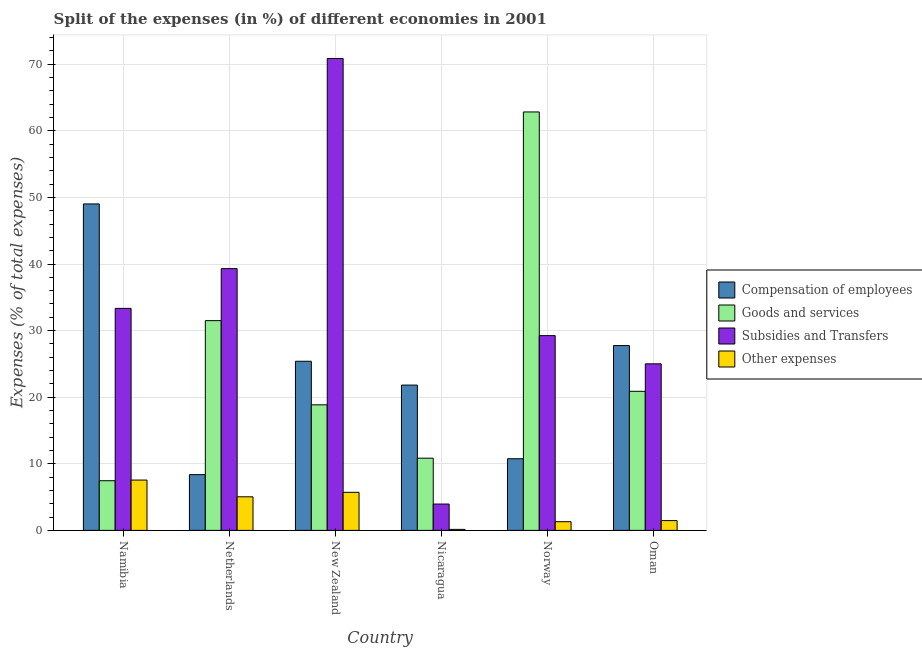How many groups of bars are there?
Keep it short and to the point. 6. What is the percentage of amount spent on subsidies in Namibia?
Offer a terse response. 33.34. Across all countries, what is the maximum percentage of amount spent on other expenses?
Provide a succinct answer. 7.56. Across all countries, what is the minimum percentage of amount spent on compensation of employees?
Offer a terse response. 8.37. In which country was the percentage of amount spent on goods and services maximum?
Make the answer very short. Norway. In which country was the percentage of amount spent on goods and services minimum?
Your response must be concise. Namibia. What is the total percentage of amount spent on other expenses in the graph?
Your answer should be very brief. 21.25. What is the difference between the percentage of amount spent on subsidies in New Zealand and that in Norway?
Give a very brief answer. 41.62. What is the difference between the percentage of amount spent on subsidies in New Zealand and the percentage of amount spent on compensation of employees in Norway?
Provide a short and direct response. 60.11. What is the average percentage of amount spent on other expenses per country?
Offer a terse response. 3.54. What is the difference between the percentage of amount spent on other expenses and percentage of amount spent on subsidies in Netherlands?
Your answer should be very brief. -34.26. In how many countries, is the percentage of amount spent on other expenses greater than 18 %?
Offer a very short reply. 0. What is the ratio of the percentage of amount spent on subsidies in Nicaragua to that in Norway?
Provide a short and direct response. 0.14. Is the difference between the percentage of amount spent on goods and services in Nicaragua and Oman greater than the difference between the percentage of amount spent on compensation of employees in Nicaragua and Oman?
Your answer should be compact. No. What is the difference between the highest and the second highest percentage of amount spent on subsidies?
Offer a terse response. 31.56. What is the difference between the highest and the lowest percentage of amount spent on compensation of employees?
Keep it short and to the point. 40.65. Is the sum of the percentage of amount spent on other expenses in Nicaragua and Oman greater than the maximum percentage of amount spent on compensation of employees across all countries?
Give a very brief answer. No. Is it the case that in every country, the sum of the percentage of amount spent on goods and services and percentage of amount spent on other expenses is greater than the sum of percentage of amount spent on subsidies and percentage of amount spent on compensation of employees?
Make the answer very short. No. What does the 4th bar from the left in Nicaragua represents?
Provide a succinct answer. Other expenses. What does the 3rd bar from the right in Oman represents?
Give a very brief answer. Goods and services. Is it the case that in every country, the sum of the percentage of amount spent on compensation of employees and percentage of amount spent on goods and services is greater than the percentage of amount spent on subsidies?
Ensure brevity in your answer.  No. How many countries are there in the graph?
Give a very brief answer. 6. Does the graph contain any zero values?
Offer a very short reply. No. Where does the legend appear in the graph?
Give a very brief answer. Center right. What is the title of the graph?
Your answer should be very brief. Split of the expenses (in %) of different economies in 2001. Does "Taxes on income" appear as one of the legend labels in the graph?
Ensure brevity in your answer.  No. What is the label or title of the Y-axis?
Provide a short and direct response. Expenses (% of total expenses). What is the Expenses (% of total expenses) of Compensation of employees in Namibia?
Your response must be concise. 49.02. What is the Expenses (% of total expenses) in Goods and services in Namibia?
Your answer should be compact. 7.46. What is the Expenses (% of total expenses) of Subsidies and Transfers in Namibia?
Your answer should be very brief. 33.34. What is the Expenses (% of total expenses) in Other expenses in Namibia?
Your answer should be very brief. 7.56. What is the Expenses (% of total expenses) in Compensation of employees in Netherlands?
Offer a terse response. 8.37. What is the Expenses (% of total expenses) in Goods and services in Netherlands?
Offer a very short reply. 31.5. What is the Expenses (% of total expenses) in Subsidies and Transfers in Netherlands?
Give a very brief answer. 39.31. What is the Expenses (% of total expenses) in Other expenses in Netherlands?
Offer a terse response. 5.04. What is the Expenses (% of total expenses) in Compensation of employees in New Zealand?
Your answer should be very brief. 25.4. What is the Expenses (% of total expenses) of Goods and services in New Zealand?
Make the answer very short. 18.85. What is the Expenses (% of total expenses) of Subsidies and Transfers in New Zealand?
Make the answer very short. 70.87. What is the Expenses (% of total expenses) in Other expenses in New Zealand?
Your answer should be compact. 5.72. What is the Expenses (% of total expenses) in Compensation of employees in Nicaragua?
Make the answer very short. 21.82. What is the Expenses (% of total expenses) in Goods and services in Nicaragua?
Ensure brevity in your answer.  10.84. What is the Expenses (% of total expenses) of Subsidies and Transfers in Nicaragua?
Your answer should be compact. 3.96. What is the Expenses (% of total expenses) of Other expenses in Nicaragua?
Your answer should be very brief. 0.15. What is the Expenses (% of total expenses) of Compensation of employees in Norway?
Offer a very short reply. 10.76. What is the Expenses (% of total expenses) in Goods and services in Norway?
Offer a very short reply. 62.83. What is the Expenses (% of total expenses) in Subsidies and Transfers in Norway?
Your answer should be very brief. 29.25. What is the Expenses (% of total expenses) of Other expenses in Norway?
Give a very brief answer. 1.31. What is the Expenses (% of total expenses) in Compensation of employees in Oman?
Offer a very short reply. 27.75. What is the Expenses (% of total expenses) of Goods and services in Oman?
Keep it short and to the point. 20.88. What is the Expenses (% of total expenses) in Subsidies and Transfers in Oman?
Provide a succinct answer. 25.01. What is the Expenses (% of total expenses) in Other expenses in Oman?
Your answer should be very brief. 1.47. Across all countries, what is the maximum Expenses (% of total expenses) in Compensation of employees?
Provide a short and direct response. 49.02. Across all countries, what is the maximum Expenses (% of total expenses) of Goods and services?
Your answer should be very brief. 62.83. Across all countries, what is the maximum Expenses (% of total expenses) of Subsidies and Transfers?
Provide a succinct answer. 70.87. Across all countries, what is the maximum Expenses (% of total expenses) of Other expenses?
Offer a very short reply. 7.56. Across all countries, what is the minimum Expenses (% of total expenses) of Compensation of employees?
Your answer should be very brief. 8.37. Across all countries, what is the minimum Expenses (% of total expenses) in Goods and services?
Provide a succinct answer. 7.46. Across all countries, what is the minimum Expenses (% of total expenses) in Subsidies and Transfers?
Make the answer very short. 3.96. Across all countries, what is the minimum Expenses (% of total expenses) in Other expenses?
Ensure brevity in your answer.  0.15. What is the total Expenses (% of total expenses) of Compensation of employees in the graph?
Your response must be concise. 143.12. What is the total Expenses (% of total expenses) of Goods and services in the graph?
Give a very brief answer. 152.37. What is the total Expenses (% of total expenses) in Subsidies and Transfers in the graph?
Provide a succinct answer. 201.72. What is the total Expenses (% of total expenses) in Other expenses in the graph?
Offer a terse response. 21.25. What is the difference between the Expenses (% of total expenses) in Compensation of employees in Namibia and that in Netherlands?
Offer a terse response. 40.65. What is the difference between the Expenses (% of total expenses) of Goods and services in Namibia and that in Netherlands?
Offer a terse response. -24.04. What is the difference between the Expenses (% of total expenses) of Subsidies and Transfers in Namibia and that in Netherlands?
Keep it short and to the point. -5.97. What is the difference between the Expenses (% of total expenses) in Other expenses in Namibia and that in Netherlands?
Provide a short and direct response. 2.51. What is the difference between the Expenses (% of total expenses) in Compensation of employees in Namibia and that in New Zealand?
Provide a succinct answer. 23.63. What is the difference between the Expenses (% of total expenses) in Goods and services in Namibia and that in New Zealand?
Make the answer very short. -11.4. What is the difference between the Expenses (% of total expenses) in Subsidies and Transfers in Namibia and that in New Zealand?
Ensure brevity in your answer.  -37.53. What is the difference between the Expenses (% of total expenses) in Other expenses in Namibia and that in New Zealand?
Make the answer very short. 1.84. What is the difference between the Expenses (% of total expenses) in Compensation of employees in Namibia and that in Nicaragua?
Provide a succinct answer. 27.2. What is the difference between the Expenses (% of total expenses) of Goods and services in Namibia and that in Nicaragua?
Provide a succinct answer. -3.38. What is the difference between the Expenses (% of total expenses) of Subsidies and Transfers in Namibia and that in Nicaragua?
Your response must be concise. 29.38. What is the difference between the Expenses (% of total expenses) of Other expenses in Namibia and that in Nicaragua?
Your answer should be compact. 7.4. What is the difference between the Expenses (% of total expenses) in Compensation of employees in Namibia and that in Norway?
Ensure brevity in your answer.  38.26. What is the difference between the Expenses (% of total expenses) in Goods and services in Namibia and that in Norway?
Your response must be concise. -55.38. What is the difference between the Expenses (% of total expenses) of Subsidies and Transfers in Namibia and that in Norway?
Your response must be concise. 4.09. What is the difference between the Expenses (% of total expenses) in Other expenses in Namibia and that in Norway?
Your response must be concise. 6.25. What is the difference between the Expenses (% of total expenses) of Compensation of employees in Namibia and that in Oman?
Keep it short and to the point. 21.27. What is the difference between the Expenses (% of total expenses) in Goods and services in Namibia and that in Oman?
Offer a terse response. -13.43. What is the difference between the Expenses (% of total expenses) in Subsidies and Transfers in Namibia and that in Oman?
Ensure brevity in your answer.  8.33. What is the difference between the Expenses (% of total expenses) of Other expenses in Namibia and that in Oman?
Ensure brevity in your answer.  6.09. What is the difference between the Expenses (% of total expenses) in Compensation of employees in Netherlands and that in New Zealand?
Make the answer very short. -17.03. What is the difference between the Expenses (% of total expenses) of Goods and services in Netherlands and that in New Zealand?
Give a very brief answer. 12.64. What is the difference between the Expenses (% of total expenses) of Subsidies and Transfers in Netherlands and that in New Zealand?
Provide a succinct answer. -31.56. What is the difference between the Expenses (% of total expenses) in Other expenses in Netherlands and that in New Zealand?
Keep it short and to the point. -0.67. What is the difference between the Expenses (% of total expenses) in Compensation of employees in Netherlands and that in Nicaragua?
Keep it short and to the point. -13.45. What is the difference between the Expenses (% of total expenses) in Goods and services in Netherlands and that in Nicaragua?
Your response must be concise. 20.65. What is the difference between the Expenses (% of total expenses) of Subsidies and Transfers in Netherlands and that in Nicaragua?
Make the answer very short. 35.35. What is the difference between the Expenses (% of total expenses) in Other expenses in Netherlands and that in Nicaragua?
Your answer should be very brief. 4.89. What is the difference between the Expenses (% of total expenses) in Compensation of employees in Netherlands and that in Norway?
Give a very brief answer. -2.39. What is the difference between the Expenses (% of total expenses) in Goods and services in Netherlands and that in Norway?
Provide a succinct answer. -31.34. What is the difference between the Expenses (% of total expenses) in Subsidies and Transfers in Netherlands and that in Norway?
Provide a succinct answer. 10.06. What is the difference between the Expenses (% of total expenses) in Other expenses in Netherlands and that in Norway?
Make the answer very short. 3.74. What is the difference between the Expenses (% of total expenses) of Compensation of employees in Netherlands and that in Oman?
Provide a short and direct response. -19.38. What is the difference between the Expenses (% of total expenses) of Goods and services in Netherlands and that in Oman?
Ensure brevity in your answer.  10.61. What is the difference between the Expenses (% of total expenses) of Subsidies and Transfers in Netherlands and that in Oman?
Keep it short and to the point. 14.3. What is the difference between the Expenses (% of total expenses) of Other expenses in Netherlands and that in Oman?
Provide a short and direct response. 3.57. What is the difference between the Expenses (% of total expenses) in Compensation of employees in New Zealand and that in Nicaragua?
Your response must be concise. 3.58. What is the difference between the Expenses (% of total expenses) of Goods and services in New Zealand and that in Nicaragua?
Offer a very short reply. 8.01. What is the difference between the Expenses (% of total expenses) of Subsidies and Transfers in New Zealand and that in Nicaragua?
Ensure brevity in your answer.  66.91. What is the difference between the Expenses (% of total expenses) of Other expenses in New Zealand and that in Nicaragua?
Provide a short and direct response. 5.57. What is the difference between the Expenses (% of total expenses) in Compensation of employees in New Zealand and that in Norway?
Ensure brevity in your answer.  14.64. What is the difference between the Expenses (% of total expenses) in Goods and services in New Zealand and that in Norway?
Make the answer very short. -43.98. What is the difference between the Expenses (% of total expenses) in Subsidies and Transfers in New Zealand and that in Norway?
Your answer should be compact. 41.62. What is the difference between the Expenses (% of total expenses) in Other expenses in New Zealand and that in Norway?
Your response must be concise. 4.41. What is the difference between the Expenses (% of total expenses) of Compensation of employees in New Zealand and that in Oman?
Your answer should be compact. -2.35. What is the difference between the Expenses (% of total expenses) in Goods and services in New Zealand and that in Oman?
Your response must be concise. -2.03. What is the difference between the Expenses (% of total expenses) in Subsidies and Transfers in New Zealand and that in Oman?
Give a very brief answer. 45.86. What is the difference between the Expenses (% of total expenses) of Other expenses in New Zealand and that in Oman?
Your answer should be compact. 4.25. What is the difference between the Expenses (% of total expenses) of Compensation of employees in Nicaragua and that in Norway?
Your answer should be compact. 11.06. What is the difference between the Expenses (% of total expenses) of Goods and services in Nicaragua and that in Norway?
Provide a short and direct response. -51.99. What is the difference between the Expenses (% of total expenses) in Subsidies and Transfers in Nicaragua and that in Norway?
Give a very brief answer. -25.29. What is the difference between the Expenses (% of total expenses) of Other expenses in Nicaragua and that in Norway?
Ensure brevity in your answer.  -1.15. What is the difference between the Expenses (% of total expenses) in Compensation of employees in Nicaragua and that in Oman?
Give a very brief answer. -5.93. What is the difference between the Expenses (% of total expenses) in Goods and services in Nicaragua and that in Oman?
Your answer should be very brief. -10.04. What is the difference between the Expenses (% of total expenses) of Subsidies and Transfers in Nicaragua and that in Oman?
Your response must be concise. -21.05. What is the difference between the Expenses (% of total expenses) in Other expenses in Nicaragua and that in Oman?
Offer a very short reply. -1.32. What is the difference between the Expenses (% of total expenses) of Compensation of employees in Norway and that in Oman?
Your response must be concise. -16.99. What is the difference between the Expenses (% of total expenses) in Goods and services in Norway and that in Oman?
Your response must be concise. 41.95. What is the difference between the Expenses (% of total expenses) of Subsidies and Transfers in Norway and that in Oman?
Your answer should be compact. 4.24. What is the difference between the Expenses (% of total expenses) in Other expenses in Norway and that in Oman?
Your response must be concise. -0.17. What is the difference between the Expenses (% of total expenses) in Compensation of employees in Namibia and the Expenses (% of total expenses) in Goods and services in Netherlands?
Provide a succinct answer. 17.53. What is the difference between the Expenses (% of total expenses) of Compensation of employees in Namibia and the Expenses (% of total expenses) of Subsidies and Transfers in Netherlands?
Give a very brief answer. 9.72. What is the difference between the Expenses (% of total expenses) in Compensation of employees in Namibia and the Expenses (% of total expenses) in Other expenses in Netherlands?
Ensure brevity in your answer.  43.98. What is the difference between the Expenses (% of total expenses) in Goods and services in Namibia and the Expenses (% of total expenses) in Subsidies and Transfers in Netherlands?
Your response must be concise. -31.85. What is the difference between the Expenses (% of total expenses) in Goods and services in Namibia and the Expenses (% of total expenses) in Other expenses in Netherlands?
Provide a short and direct response. 2.41. What is the difference between the Expenses (% of total expenses) of Subsidies and Transfers in Namibia and the Expenses (% of total expenses) of Other expenses in Netherlands?
Provide a short and direct response. 28.29. What is the difference between the Expenses (% of total expenses) of Compensation of employees in Namibia and the Expenses (% of total expenses) of Goods and services in New Zealand?
Keep it short and to the point. 30.17. What is the difference between the Expenses (% of total expenses) in Compensation of employees in Namibia and the Expenses (% of total expenses) in Subsidies and Transfers in New Zealand?
Your answer should be compact. -21.84. What is the difference between the Expenses (% of total expenses) in Compensation of employees in Namibia and the Expenses (% of total expenses) in Other expenses in New Zealand?
Ensure brevity in your answer.  43.31. What is the difference between the Expenses (% of total expenses) in Goods and services in Namibia and the Expenses (% of total expenses) in Subsidies and Transfers in New Zealand?
Provide a succinct answer. -63.41. What is the difference between the Expenses (% of total expenses) of Goods and services in Namibia and the Expenses (% of total expenses) of Other expenses in New Zealand?
Your response must be concise. 1.74. What is the difference between the Expenses (% of total expenses) of Subsidies and Transfers in Namibia and the Expenses (% of total expenses) of Other expenses in New Zealand?
Keep it short and to the point. 27.62. What is the difference between the Expenses (% of total expenses) of Compensation of employees in Namibia and the Expenses (% of total expenses) of Goods and services in Nicaragua?
Keep it short and to the point. 38.18. What is the difference between the Expenses (% of total expenses) of Compensation of employees in Namibia and the Expenses (% of total expenses) of Subsidies and Transfers in Nicaragua?
Keep it short and to the point. 45.07. What is the difference between the Expenses (% of total expenses) in Compensation of employees in Namibia and the Expenses (% of total expenses) in Other expenses in Nicaragua?
Provide a succinct answer. 48.87. What is the difference between the Expenses (% of total expenses) of Goods and services in Namibia and the Expenses (% of total expenses) of Subsidies and Transfers in Nicaragua?
Your answer should be compact. 3.5. What is the difference between the Expenses (% of total expenses) of Goods and services in Namibia and the Expenses (% of total expenses) of Other expenses in Nicaragua?
Give a very brief answer. 7.31. What is the difference between the Expenses (% of total expenses) of Subsidies and Transfers in Namibia and the Expenses (% of total expenses) of Other expenses in Nicaragua?
Your answer should be compact. 33.18. What is the difference between the Expenses (% of total expenses) in Compensation of employees in Namibia and the Expenses (% of total expenses) in Goods and services in Norway?
Give a very brief answer. -13.81. What is the difference between the Expenses (% of total expenses) in Compensation of employees in Namibia and the Expenses (% of total expenses) in Subsidies and Transfers in Norway?
Provide a short and direct response. 19.78. What is the difference between the Expenses (% of total expenses) in Compensation of employees in Namibia and the Expenses (% of total expenses) in Other expenses in Norway?
Your response must be concise. 47.72. What is the difference between the Expenses (% of total expenses) of Goods and services in Namibia and the Expenses (% of total expenses) of Subsidies and Transfers in Norway?
Your response must be concise. -21.79. What is the difference between the Expenses (% of total expenses) of Goods and services in Namibia and the Expenses (% of total expenses) of Other expenses in Norway?
Give a very brief answer. 6.15. What is the difference between the Expenses (% of total expenses) in Subsidies and Transfers in Namibia and the Expenses (% of total expenses) in Other expenses in Norway?
Offer a terse response. 32.03. What is the difference between the Expenses (% of total expenses) in Compensation of employees in Namibia and the Expenses (% of total expenses) in Goods and services in Oman?
Your answer should be compact. 28.14. What is the difference between the Expenses (% of total expenses) in Compensation of employees in Namibia and the Expenses (% of total expenses) in Subsidies and Transfers in Oman?
Your response must be concise. 24.01. What is the difference between the Expenses (% of total expenses) of Compensation of employees in Namibia and the Expenses (% of total expenses) of Other expenses in Oman?
Provide a short and direct response. 47.55. What is the difference between the Expenses (% of total expenses) in Goods and services in Namibia and the Expenses (% of total expenses) in Subsidies and Transfers in Oman?
Your response must be concise. -17.55. What is the difference between the Expenses (% of total expenses) in Goods and services in Namibia and the Expenses (% of total expenses) in Other expenses in Oman?
Offer a terse response. 5.99. What is the difference between the Expenses (% of total expenses) in Subsidies and Transfers in Namibia and the Expenses (% of total expenses) in Other expenses in Oman?
Provide a succinct answer. 31.87. What is the difference between the Expenses (% of total expenses) of Compensation of employees in Netherlands and the Expenses (% of total expenses) of Goods and services in New Zealand?
Your answer should be compact. -10.48. What is the difference between the Expenses (% of total expenses) of Compensation of employees in Netherlands and the Expenses (% of total expenses) of Subsidies and Transfers in New Zealand?
Keep it short and to the point. -62.5. What is the difference between the Expenses (% of total expenses) of Compensation of employees in Netherlands and the Expenses (% of total expenses) of Other expenses in New Zealand?
Your answer should be compact. 2.65. What is the difference between the Expenses (% of total expenses) in Goods and services in Netherlands and the Expenses (% of total expenses) in Subsidies and Transfers in New Zealand?
Your answer should be very brief. -39.37. What is the difference between the Expenses (% of total expenses) in Goods and services in Netherlands and the Expenses (% of total expenses) in Other expenses in New Zealand?
Provide a succinct answer. 25.78. What is the difference between the Expenses (% of total expenses) in Subsidies and Transfers in Netherlands and the Expenses (% of total expenses) in Other expenses in New Zealand?
Offer a very short reply. 33.59. What is the difference between the Expenses (% of total expenses) in Compensation of employees in Netherlands and the Expenses (% of total expenses) in Goods and services in Nicaragua?
Your answer should be very brief. -2.47. What is the difference between the Expenses (% of total expenses) of Compensation of employees in Netherlands and the Expenses (% of total expenses) of Subsidies and Transfers in Nicaragua?
Ensure brevity in your answer.  4.41. What is the difference between the Expenses (% of total expenses) of Compensation of employees in Netherlands and the Expenses (% of total expenses) of Other expenses in Nicaragua?
Offer a terse response. 8.22. What is the difference between the Expenses (% of total expenses) of Goods and services in Netherlands and the Expenses (% of total expenses) of Subsidies and Transfers in Nicaragua?
Your answer should be very brief. 27.54. What is the difference between the Expenses (% of total expenses) in Goods and services in Netherlands and the Expenses (% of total expenses) in Other expenses in Nicaragua?
Offer a terse response. 31.34. What is the difference between the Expenses (% of total expenses) in Subsidies and Transfers in Netherlands and the Expenses (% of total expenses) in Other expenses in Nicaragua?
Your answer should be very brief. 39.16. What is the difference between the Expenses (% of total expenses) of Compensation of employees in Netherlands and the Expenses (% of total expenses) of Goods and services in Norway?
Give a very brief answer. -54.47. What is the difference between the Expenses (% of total expenses) of Compensation of employees in Netherlands and the Expenses (% of total expenses) of Subsidies and Transfers in Norway?
Your response must be concise. -20.88. What is the difference between the Expenses (% of total expenses) in Compensation of employees in Netherlands and the Expenses (% of total expenses) in Other expenses in Norway?
Make the answer very short. 7.06. What is the difference between the Expenses (% of total expenses) in Goods and services in Netherlands and the Expenses (% of total expenses) in Subsidies and Transfers in Norway?
Provide a short and direct response. 2.25. What is the difference between the Expenses (% of total expenses) of Goods and services in Netherlands and the Expenses (% of total expenses) of Other expenses in Norway?
Your response must be concise. 30.19. What is the difference between the Expenses (% of total expenses) of Subsidies and Transfers in Netherlands and the Expenses (% of total expenses) of Other expenses in Norway?
Your answer should be very brief. 38. What is the difference between the Expenses (% of total expenses) of Compensation of employees in Netherlands and the Expenses (% of total expenses) of Goods and services in Oman?
Make the answer very short. -12.52. What is the difference between the Expenses (% of total expenses) in Compensation of employees in Netherlands and the Expenses (% of total expenses) in Subsidies and Transfers in Oman?
Your answer should be compact. -16.64. What is the difference between the Expenses (% of total expenses) in Compensation of employees in Netherlands and the Expenses (% of total expenses) in Other expenses in Oman?
Give a very brief answer. 6.9. What is the difference between the Expenses (% of total expenses) in Goods and services in Netherlands and the Expenses (% of total expenses) in Subsidies and Transfers in Oman?
Your response must be concise. 6.49. What is the difference between the Expenses (% of total expenses) of Goods and services in Netherlands and the Expenses (% of total expenses) of Other expenses in Oman?
Offer a terse response. 30.02. What is the difference between the Expenses (% of total expenses) of Subsidies and Transfers in Netherlands and the Expenses (% of total expenses) of Other expenses in Oman?
Your answer should be compact. 37.84. What is the difference between the Expenses (% of total expenses) in Compensation of employees in New Zealand and the Expenses (% of total expenses) in Goods and services in Nicaragua?
Provide a succinct answer. 14.55. What is the difference between the Expenses (% of total expenses) in Compensation of employees in New Zealand and the Expenses (% of total expenses) in Subsidies and Transfers in Nicaragua?
Provide a succinct answer. 21.44. What is the difference between the Expenses (% of total expenses) of Compensation of employees in New Zealand and the Expenses (% of total expenses) of Other expenses in Nicaragua?
Offer a terse response. 25.24. What is the difference between the Expenses (% of total expenses) of Goods and services in New Zealand and the Expenses (% of total expenses) of Subsidies and Transfers in Nicaragua?
Keep it short and to the point. 14.9. What is the difference between the Expenses (% of total expenses) in Goods and services in New Zealand and the Expenses (% of total expenses) in Other expenses in Nicaragua?
Ensure brevity in your answer.  18.7. What is the difference between the Expenses (% of total expenses) of Subsidies and Transfers in New Zealand and the Expenses (% of total expenses) of Other expenses in Nicaragua?
Your answer should be very brief. 70.71. What is the difference between the Expenses (% of total expenses) in Compensation of employees in New Zealand and the Expenses (% of total expenses) in Goods and services in Norway?
Offer a terse response. -37.44. What is the difference between the Expenses (% of total expenses) in Compensation of employees in New Zealand and the Expenses (% of total expenses) in Subsidies and Transfers in Norway?
Your answer should be very brief. -3.85. What is the difference between the Expenses (% of total expenses) of Compensation of employees in New Zealand and the Expenses (% of total expenses) of Other expenses in Norway?
Give a very brief answer. 24.09. What is the difference between the Expenses (% of total expenses) of Goods and services in New Zealand and the Expenses (% of total expenses) of Subsidies and Transfers in Norway?
Give a very brief answer. -10.39. What is the difference between the Expenses (% of total expenses) of Goods and services in New Zealand and the Expenses (% of total expenses) of Other expenses in Norway?
Your answer should be compact. 17.55. What is the difference between the Expenses (% of total expenses) of Subsidies and Transfers in New Zealand and the Expenses (% of total expenses) of Other expenses in Norway?
Ensure brevity in your answer.  69.56. What is the difference between the Expenses (% of total expenses) in Compensation of employees in New Zealand and the Expenses (% of total expenses) in Goods and services in Oman?
Give a very brief answer. 4.51. What is the difference between the Expenses (% of total expenses) in Compensation of employees in New Zealand and the Expenses (% of total expenses) in Subsidies and Transfers in Oman?
Keep it short and to the point. 0.39. What is the difference between the Expenses (% of total expenses) of Compensation of employees in New Zealand and the Expenses (% of total expenses) of Other expenses in Oman?
Make the answer very short. 23.93. What is the difference between the Expenses (% of total expenses) in Goods and services in New Zealand and the Expenses (% of total expenses) in Subsidies and Transfers in Oman?
Offer a very short reply. -6.16. What is the difference between the Expenses (% of total expenses) of Goods and services in New Zealand and the Expenses (% of total expenses) of Other expenses in Oman?
Give a very brief answer. 17.38. What is the difference between the Expenses (% of total expenses) of Subsidies and Transfers in New Zealand and the Expenses (% of total expenses) of Other expenses in Oman?
Ensure brevity in your answer.  69.39. What is the difference between the Expenses (% of total expenses) of Compensation of employees in Nicaragua and the Expenses (% of total expenses) of Goods and services in Norway?
Provide a short and direct response. -41.01. What is the difference between the Expenses (% of total expenses) of Compensation of employees in Nicaragua and the Expenses (% of total expenses) of Subsidies and Transfers in Norway?
Your answer should be compact. -7.43. What is the difference between the Expenses (% of total expenses) in Compensation of employees in Nicaragua and the Expenses (% of total expenses) in Other expenses in Norway?
Your answer should be very brief. 20.52. What is the difference between the Expenses (% of total expenses) of Goods and services in Nicaragua and the Expenses (% of total expenses) of Subsidies and Transfers in Norway?
Your answer should be very brief. -18.4. What is the difference between the Expenses (% of total expenses) of Goods and services in Nicaragua and the Expenses (% of total expenses) of Other expenses in Norway?
Your answer should be very brief. 9.54. What is the difference between the Expenses (% of total expenses) in Subsidies and Transfers in Nicaragua and the Expenses (% of total expenses) in Other expenses in Norway?
Make the answer very short. 2.65. What is the difference between the Expenses (% of total expenses) of Compensation of employees in Nicaragua and the Expenses (% of total expenses) of Goods and services in Oman?
Provide a short and direct response. 0.94. What is the difference between the Expenses (% of total expenses) in Compensation of employees in Nicaragua and the Expenses (% of total expenses) in Subsidies and Transfers in Oman?
Provide a short and direct response. -3.19. What is the difference between the Expenses (% of total expenses) in Compensation of employees in Nicaragua and the Expenses (% of total expenses) in Other expenses in Oman?
Keep it short and to the point. 20.35. What is the difference between the Expenses (% of total expenses) of Goods and services in Nicaragua and the Expenses (% of total expenses) of Subsidies and Transfers in Oman?
Offer a terse response. -14.17. What is the difference between the Expenses (% of total expenses) in Goods and services in Nicaragua and the Expenses (% of total expenses) in Other expenses in Oman?
Your answer should be very brief. 9.37. What is the difference between the Expenses (% of total expenses) in Subsidies and Transfers in Nicaragua and the Expenses (% of total expenses) in Other expenses in Oman?
Give a very brief answer. 2.49. What is the difference between the Expenses (% of total expenses) of Compensation of employees in Norway and the Expenses (% of total expenses) of Goods and services in Oman?
Offer a very short reply. -10.13. What is the difference between the Expenses (% of total expenses) in Compensation of employees in Norway and the Expenses (% of total expenses) in Subsidies and Transfers in Oman?
Offer a very short reply. -14.25. What is the difference between the Expenses (% of total expenses) of Compensation of employees in Norway and the Expenses (% of total expenses) of Other expenses in Oman?
Your answer should be very brief. 9.29. What is the difference between the Expenses (% of total expenses) of Goods and services in Norway and the Expenses (% of total expenses) of Subsidies and Transfers in Oman?
Give a very brief answer. 37.83. What is the difference between the Expenses (% of total expenses) of Goods and services in Norway and the Expenses (% of total expenses) of Other expenses in Oman?
Offer a very short reply. 61.36. What is the difference between the Expenses (% of total expenses) in Subsidies and Transfers in Norway and the Expenses (% of total expenses) in Other expenses in Oman?
Ensure brevity in your answer.  27.78. What is the average Expenses (% of total expenses) in Compensation of employees per country?
Make the answer very short. 23.85. What is the average Expenses (% of total expenses) of Goods and services per country?
Offer a terse response. 25.39. What is the average Expenses (% of total expenses) of Subsidies and Transfers per country?
Keep it short and to the point. 33.62. What is the average Expenses (% of total expenses) in Other expenses per country?
Offer a terse response. 3.54. What is the difference between the Expenses (% of total expenses) in Compensation of employees and Expenses (% of total expenses) in Goods and services in Namibia?
Keep it short and to the point. 41.57. What is the difference between the Expenses (% of total expenses) in Compensation of employees and Expenses (% of total expenses) in Subsidies and Transfers in Namibia?
Your response must be concise. 15.69. What is the difference between the Expenses (% of total expenses) of Compensation of employees and Expenses (% of total expenses) of Other expenses in Namibia?
Your response must be concise. 41.47. What is the difference between the Expenses (% of total expenses) of Goods and services and Expenses (% of total expenses) of Subsidies and Transfers in Namibia?
Make the answer very short. -25.88. What is the difference between the Expenses (% of total expenses) in Goods and services and Expenses (% of total expenses) in Other expenses in Namibia?
Ensure brevity in your answer.  -0.1. What is the difference between the Expenses (% of total expenses) in Subsidies and Transfers and Expenses (% of total expenses) in Other expenses in Namibia?
Your response must be concise. 25.78. What is the difference between the Expenses (% of total expenses) of Compensation of employees and Expenses (% of total expenses) of Goods and services in Netherlands?
Provide a short and direct response. -23.13. What is the difference between the Expenses (% of total expenses) of Compensation of employees and Expenses (% of total expenses) of Subsidies and Transfers in Netherlands?
Ensure brevity in your answer.  -30.94. What is the difference between the Expenses (% of total expenses) in Compensation of employees and Expenses (% of total expenses) in Other expenses in Netherlands?
Offer a very short reply. 3.33. What is the difference between the Expenses (% of total expenses) in Goods and services and Expenses (% of total expenses) in Subsidies and Transfers in Netherlands?
Provide a short and direct response. -7.81. What is the difference between the Expenses (% of total expenses) in Goods and services and Expenses (% of total expenses) in Other expenses in Netherlands?
Provide a succinct answer. 26.45. What is the difference between the Expenses (% of total expenses) in Subsidies and Transfers and Expenses (% of total expenses) in Other expenses in Netherlands?
Give a very brief answer. 34.26. What is the difference between the Expenses (% of total expenses) of Compensation of employees and Expenses (% of total expenses) of Goods and services in New Zealand?
Provide a succinct answer. 6.54. What is the difference between the Expenses (% of total expenses) in Compensation of employees and Expenses (% of total expenses) in Subsidies and Transfers in New Zealand?
Provide a succinct answer. -45.47. What is the difference between the Expenses (% of total expenses) in Compensation of employees and Expenses (% of total expenses) in Other expenses in New Zealand?
Your response must be concise. 19.68. What is the difference between the Expenses (% of total expenses) of Goods and services and Expenses (% of total expenses) of Subsidies and Transfers in New Zealand?
Ensure brevity in your answer.  -52.01. What is the difference between the Expenses (% of total expenses) in Goods and services and Expenses (% of total expenses) in Other expenses in New Zealand?
Ensure brevity in your answer.  13.14. What is the difference between the Expenses (% of total expenses) of Subsidies and Transfers and Expenses (% of total expenses) of Other expenses in New Zealand?
Ensure brevity in your answer.  65.15. What is the difference between the Expenses (% of total expenses) in Compensation of employees and Expenses (% of total expenses) in Goods and services in Nicaragua?
Your answer should be compact. 10.98. What is the difference between the Expenses (% of total expenses) in Compensation of employees and Expenses (% of total expenses) in Subsidies and Transfers in Nicaragua?
Your answer should be very brief. 17.86. What is the difference between the Expenses (% of total expenses) in Compensation of employees and Expenses (% of total expenses) in Other expenses in Nicaragua?
Make the answer very short. 21.67. What is the difference between the Expenses (% of total expenses) in Goods and services and Expenses (% of total expenses) in Subsidies and Transfers in Nicaragua?
Provide a short and direct response. 6.89. What is the difference between the Expenses (% of total expenses) of Goods and services and Expenses (% of total expenses) of Other expenses in Nicaragua?
Give a very brief answer. 10.69. What is the difference between the Expenses (% of total expenses) in Subsidies and Transfers and Expenses (% of total expenses) in Other expenses in Nicaragua?
Your response must be concise. 3.8. What is the difference between the Expenses (% of total expenses) of Compensation of employees and Expenses (% of total expenses) of Goods and services in Norway?
Ensure brevity in your answer.  -52.08. What is the difference between the Expenses (% of total expenses) of Compensation of employees and Expenses (% of total expenses) of Subsidies and Transfers in Norway?
Provide a succinct answer. -18.49. What is the difference between the Expenses (% of total expenses) in Compensation of employees and Expenses (% of total expenses) in Other expenses in Norway?
Provide a short and direct response. 9.45. What is the difference between the Expenses (% of total expenses) of Goods and services and Expenses (% of total expenses) of Subsidies and Transfers in Norway?
Provide a succinct answer. 33.59. What is the difference between the Expenses (% of total expenses) of Goods and services and Expenses (% of total expenses) of Other expenses in Norway?
Your answer should be very brief. 61.53. What is the difference between the Expenses (% of total expenses) of Subsidies and Transfers and Expenses (% of total expenses) of Other expenses in Norway?
Offer a very short reply. 27.94. What is the difference between the Expenses (% of total expenses) in Compensation of employees and Expenses (% of total expenses) in Goods and services in Oman?
Your response must be concise. 6.87. What is the difference between the Expenses (% of total expenses) in Compensation of employees and Expenses (% of total expenses) in Subsidies and Transfers in Oman?
Your response must be concise. 2.74. What is the difference between the Expenses (% of total expenses) in Compensation of employees and Expenses (% of total expenses) in Other expenses in Oman?
Your response must be concise. 26.28. What is the difference between the Expenses (% of total expenses) of Goods and services and Expenses (% of total expenses) of Subsidies and Transfers in Oman?
Your answer should be very brief. -4.12. What is the difference between the Expenses (% of total expenses) in Goods and services and Expenses (% of total expenses) in Other expenses in Oman?
Your answer should be compact. 19.41. What is the difference between the Expenses (% of total expenses) in Subsidies and Transfers and Expenses (% of total expenses) in Other expenses in Oman?
Your answer should be compact. 23.54. What is the ratio of the Expenses (% of total expenses) of Compensation of employees in Namibia to that in Netherlands?
Keep it short and to the point. 5.86. What is the ratio of the Expenses (% of total expenses) in Goods and services in Namibia to that in Netherlands?
Ensure brevity in your answer.  0.24. What is the ratio of the Expenses (% of total expenses) in Subsidies and Transfers in Namibia to that in Netherlands?
Your response must be concise. 0.85. What is the ratio of the Expenses (% of total expenses) in Other expenses in Namibia to that in Netherlands?
Your response must be concise. 1.5. What is the ratio of the Expenses (% of total expenses) in Compensation of employees in Namibia to that in New Zealand?
Ensure brevity in your answer.  1.93. What is the ratio of the Expenses (% of total expenses) in Goods and services in Namibia to that in New Zealand?
Make the answer very short. 0.4. What is the ratio of the Expenses (% of total expenses) in Subsidies and Transfers in Namibia to that in New Zealand?
Your answer should be very brief. 0.47. What is the ratio of the Expenses (% of total expenses) in Other expenses in Namibia to that in New Zealand?
Provide a short and direct response. 1.32. What is the ratio of the Expenses (% of total expenses) in Compensation of employees in Namibia to that in Nicaragua?
Give a very brief answer. 2.25. What is the ratio of the Expenses (% of total expenses) in Goods and services in Namibia to that in Nicaragua?
Your answer should be very brief. 0.69. What is the ratio of the Expenses (% of total expenses) of Subsidies and Transfers in Namibia to that in Nicaragua?
Offer a very short reply. 8.42. What is the ratio of the Expenses (% of total expenses) in Other expenses in Namibia to that in Nicaragua?
Keep it short and to the point. 49.64. What is the ratio of the Expenses (% of total expenses) of Compensation of employees in Namibia to that in Norway?
Provide a succinct answer. 4.56. What is the ratio of the Expenses (% of total expenses) of Goods and services in Namibia to that in Norway?
Your answer should be very brief. 0.12. What is the ratio of the Expenses (% of total expenses) of Subsidies and Transfers in Namibia to that in Norway?
Offer a terse response. 1.14. What is the ratio of the Expenses (% of total expenses) in Other expenses in Namibia to that in Norway?
Offer a terse response. 5.79. What is the ratio of the Expenses (% of total expenses) in Compensation of employees in Namibia to that in Oman?
Provide a short and direct response. 1.77. What is the ratio of the Expenses (% of total expenses) in Goods and services in Namibia to that in Oman?
Offer a very short reply. 0.36. What is the ratio of the Expenses (% of total expenses) of Subsidies and Transfers in Namibia to that in Oman?
Make the answer very short. 1.33. What is the ratio of the Expenses (% of total expenses) in Other expenses in Namibia to that in Oman?
Make the answer very short. 5.14. What is the ratio of the Expenses (% of total expenses) in Compensation of employees in Netherlands to that in New Zealand?
Your response must be concise. 0.33. What is the ratio of the Expenses (% of total expenses) of Goods and services in Netherlands to that in New Zealand?
Your response must be concise. 1.67. What is the ratio of the Expenses (% of total expenses) in Subsidies and Transfers in Netherlands to that in New Zealand?
Your answer should be very brief. 0.55. What is the ratio of the Expenses (% of total expenses) of Other expenses in Netherlands to that in New Zealand?
Your answer should be very brief. 0.88. What is the ratio of the Expenses (% of total expenses) of Compensation of employees in Netherlands to that in Nicaragua?
Your response must be concise. 0.38. What is the ratio of the Expenses (% of total expenses) in Goods and services in Netherlands to that in Nicaragua?
Offer a very short reply. 2.9. What is the ratio of the Expenses (% of total expenses) of Subsidies and Transfers in Netherlands to that in Nicaragua?
Your answer should be very brief. 9.93. What is the ratio of the Expenses (% of total expenses) in Other expenses in Netherlands to that in Nicaragua?
Your response must be concise. 33.14. What is the ratio of the Expenses (% of total expenses) in Compensation of employees in Netherlands to that in Norway?
Your answer should be compact. 0.78. What is the ratio of the Expenses (% of total expenses) of Goods and services in Netherlands to that in Norway?
Keep it short and to the point. 0.5. What is the ratio of the Expenses (% of total expenses) in Subsidies and Transfers in Netherlands to that in Norway?
Provide a short and direct response. 1.34. What is the ratio of the Expenses (% of total expenses) of Other expenses in Netherlands to that in Norway?
Provide a succinct answer. 3.87. What is the ratio of the Expenses (% of total expenses) of Compensation of employees in Netherlands to that in Oman?
Keep it short and to the point. 0.3. What is the ratio of the Expenses (% of total expenses) in Goods and services in Netherlands to that in Oman?
Your response must be concise. 1.51. What is the ratio of the Expenses (% of total expenses) of Subsidies and Transfers in Netherlands to that in Oman?
Provide a short and direct response. 1.57. What is the ratio of the Expenses (% of total expenses) in Other expenses in Netherlands to that in Oman?
Offer a terse response. 3.43. What is the ratio of the Expenses (% of total expenses) in Compensation of employees in New Zealand to that in Nicaragua?
Offer a very short reply. 1.16. What is the ratio of the Expenses (% of total expenses) in Goods and services in New Zealand to that in Nicaragua?
Your answer should be very brief. 1.74. What is the ratio of the Expenses (% of total expenses) of Subsidies and Transfers in New Zealand to that in Nicaragua?
Your response must be concise. 17.91. What is the ratio of the Expenses (% of total expenses) in Other expenses in New Zealand to that in Nicaragua?
Offer a terse response. 37.56. What is the ratio of the Expenses (% of total expenses) in Compensation of employees in New Zealand to that in Norway?
Your response must be concise. 2.36. What is the ratio of the Expenses (% of total expenses) in Goods and services in New Zealand to that in Norway?
Offer a very short reply. 0.3. What is the ratio of the Expenses (% of total expenses) in Subsidies and Transfers in New Zealand to that in Norway?
Offer a terse response. 2.42. What is the ratio of the Expenses (% of total expenses) in Other expenses in New Zealand to that in Norway?
Your answer should be compact. 4.38. What is the ratio of the Expenses (% of total expenses) in Compensation of employees in New Zealand to that in Oman?
Offer a terse response. 0.92. What is the ratio of the Expenses (% of total expenses) of Goods and services in New Zealand to that in Oman?
Make the answer very short. 0.9. What is the ratio of the Expenses (% of total expenses) of Subsidies and Transfers in New Zealand to that in Oman?
Make the answer very short. 2.83. What is the ratio of the Expenses (% of total expenses) of Other expenses in New Zealand to that in Oman?
Your response must be concise. 3.89. What is the ratio of the Expenses (% of total expenses) of Compensation of employees in Nicaragua to that in Norway?
Offer a terse response. 2.03. What is the ratio of the Expenses (% of total expenses) in Goods and services in Nicaragua to that in Norway?
Provide a short and direct response. 0.17. What is the ratio of the Expenses (% of total expenses) of Subsidies and Transfers in Nicaragua to that in Norway?
Your response must be concise. 0.14. What is the ratio of the Expenses (% of total expenses) of Other expenses in Nicaragua to that in Norway?
Provide a succinct answer. 0.12. What is the ratio of the Expenses (% of total expenses) in Compensation of employees in Nicaragua to that in Oman?
Ensure brevity in your answer.  0.79. What is the ratio of the Expenses (% of total expenses) in Goods and services in Nicaragua to that in Oman?
Your answer should be compact. 0.52. What is the ratio of the Expenses (% of total expenses) of Subsidies and Transfers in Nicaragua to that in Oman?
Make the answer very short. 0.16. What is the ratio of the Expenses (% of total expenses) of Other expenses in Nicaragua to that in Oman?
Offer a very short reply. 0.1. What is the ratio of the Expenses (% of total expenses) of Compensation of employees in Norway to that in Oman?
Give a very brief answer. 0.39. What is the ratio of the Expenses (% of total expenses) in Goods and services in Norway to that in Oman?
Your answer should be compact. 3.01. What is the ratio of the Expenses (% of total expenses) of Subsidies and Transfers in Norway to that in Oman?
Keep it short and to the point. 1.17. What is the ratio of the Expenses (% of total expenses) in Other expenses in Norway to that in Oman?
Your response must be concise. 0.89. What is the difference between the highest and the second highest Expenses (% of total expenses) of Compensation of employees?
Your response must be concise. 21.27. What is the difference between the highest and the second highest Expenses (% of total expenses) in Goods and services?
Keep it short and to the point. 31.34. What is the difference between the highest and the second highest Expenses (% of total expenses) of Subsidies and Transfers?
Offer a very short reply. 31.56. What is the difference between the highest and the second highest Expenses (% of total expenses) of Other expenses?
Your answer should be very brief. 1.84. What is the difference between the highest and the lowest Expenses (% of total expenses) in Compensation of employees?
Keep it short and to the point. 40.65. What is the difference between the highest and the lowest Expenses (% of total expenses) of Goods and services?
Your answer should be very brief. 55.38. What is the difference between the highest and the lowest Expenses (% of total expenses) of Subsidies and Transfers?
Offer a terse response. 66.91. What is the difference between the highest and the lowest Expenses (% of total expenses) of Other expenses?
Provide a short and direct response. 7.4. 